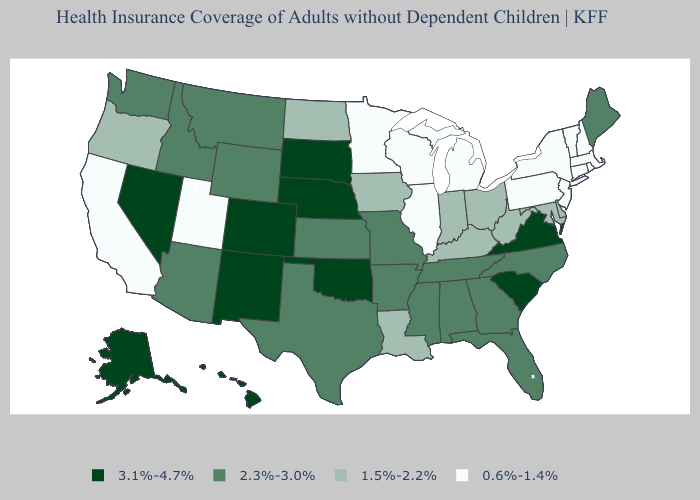Does the first symbol in the legend represent the smallest category?
Answer briefly. No. Does New Mexico have the highest value in the USA?
Quick response, please. Yes. What is the lowest value in the USA?
Quick response, please. 0.6%-1.4%. Which states have the highest value in the USA?
Answer briefly. Alaska, Colorado, Hawaii, Nebraska, Nevada, New Mexico, Oklahoma, South Carolina, South Dakota, Virginia. Which states have the lowest value in the MidWest?
Short answer required. Illinois, Michigan, Minnesota, Wisconsin. Name the states that have a value in the range 0.6%-1.4%?
Keep it brief. California, Connecticut, Illinois, Massachusetts, Michigan, Minnesota, New Hampshire, New Jersey, New York, Pennsylvania, Rhode Island, Utah, Vermont, Wisconsin. Does the first symbol in the legend represent the smallest category?
Write a very short answer. No. How many symbols are there in the legend?
Short answer required. 4. Does Tennessee have a higher value than Virginia?
Concise answer only. No. Does South Dakota have the highest value in the USA?
Keep it brief. Yes. Does Montana have the lowest value in the USA?
Answer briefly. No. Among the states that border Mississippi , which have the highest value?
Answer briefly. Alabama, Arkansas, Tennessee. Is the legend a continuous bar?
Keep it brief. No. Does Texas have the lowest value in the South?
Keep it brief. No. 